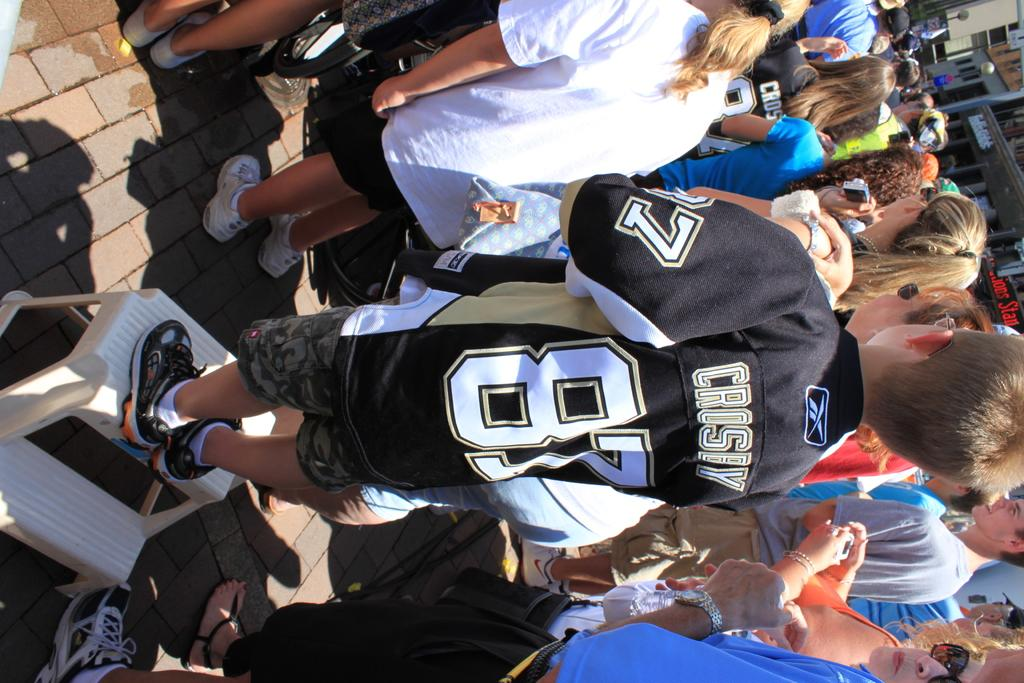<image>
Provide a brief description of the given image. A young person is wearing a jersey with the name Crosby on the back. 